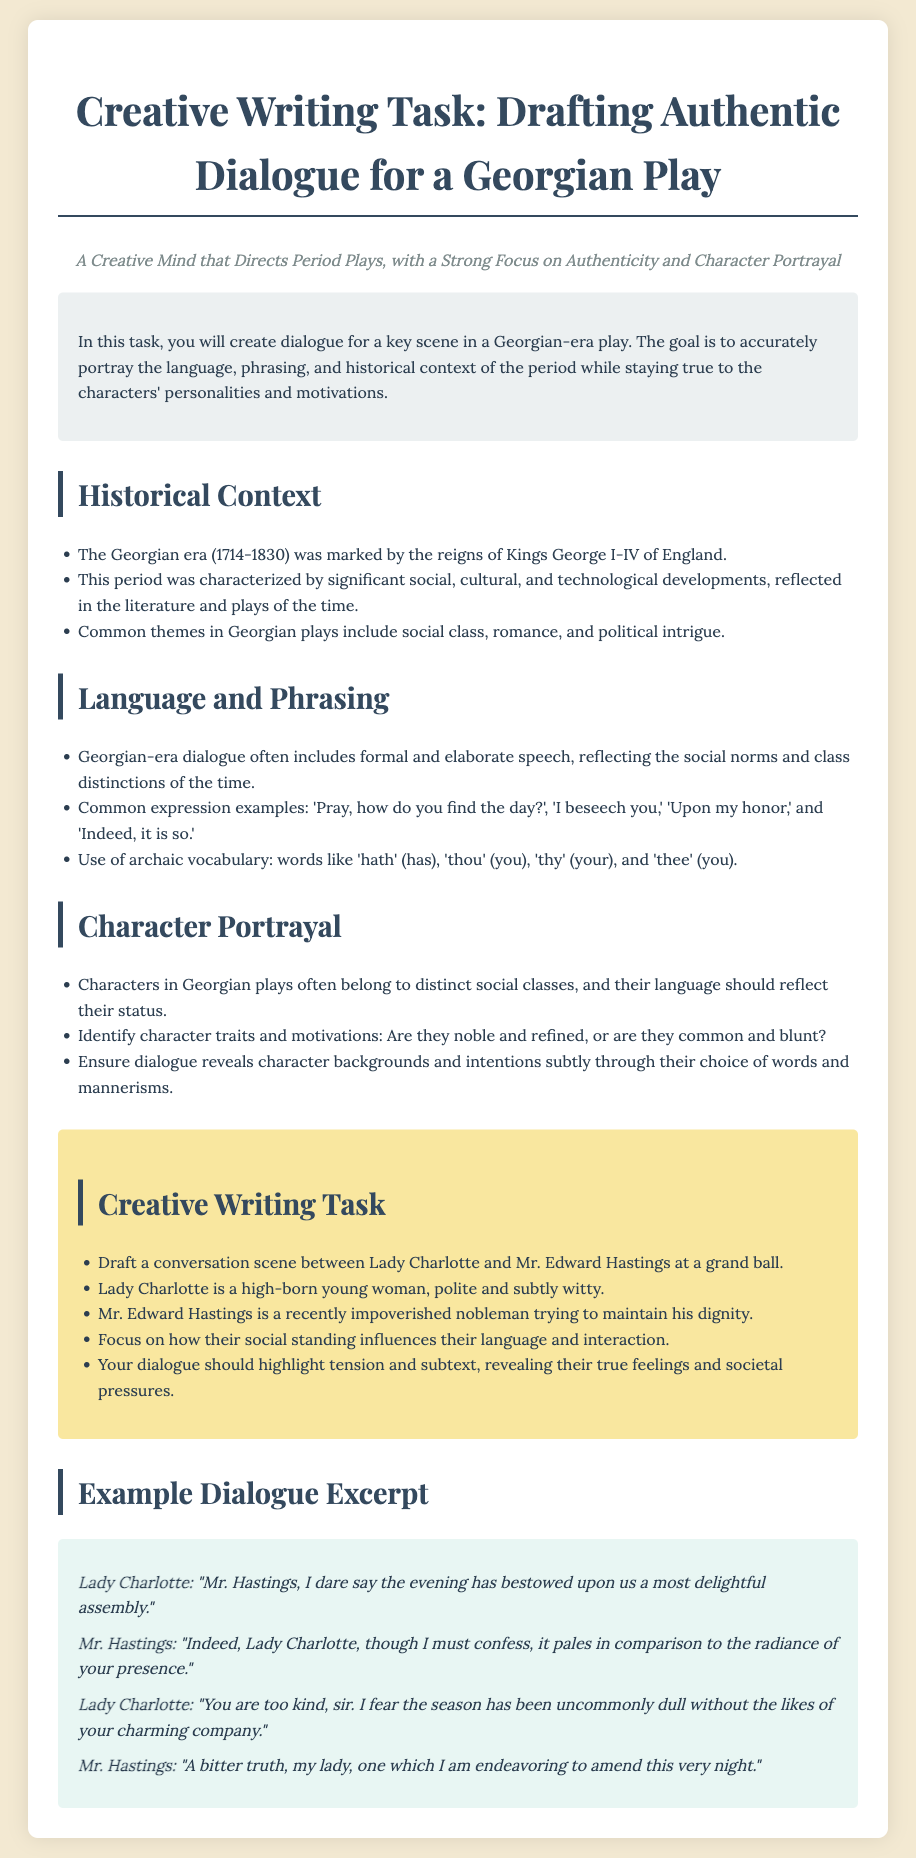What is the main focus of the creative writing task? The task focuses on drafting authentic dialogue for a Georgian-era play while emphasizing language, phrasing, and historical accuracy.
Answer: authentic dialogue What are the names of the two characters in the conversation scene? The characters in the scene are Lady Charlotte and Mr. Edward Hastings.
Answer: Lady Charlotte and Mr. Edward Hastings Which era is the play set in? The play is set in the Georgian era, specifically during the reigns of Kings George I-IV of England.
Answer: Georgian era What expression is recommended for use in dialogue? The document lists several expressions, including 'I beseech you.'
Answer: I beseech you What overarching theme is common in Georgian plays? Common themes in Georgian plays include social class, romance, and political intrigue.
Answer: social class, romance, and political intrigue What is Mr. Edward Hastings' social status following his misfortune? Mr. Edward Hastings is described as a recently impoverished nobleman.
Answer: impoverished nobleman What character trait should Lady Charlotte display? Lady Charlotte is depicted as polite and subtly witty.
Answer: polite and subtly witty In which setting does the character interaction take place? The interaction occurs at a grand ball.
Answer: grand ball What is the suggested writing focus for the dialogue? The writing should focus on how their social standing influences their language and interaction.
Answer: social standing influences language and interaction 